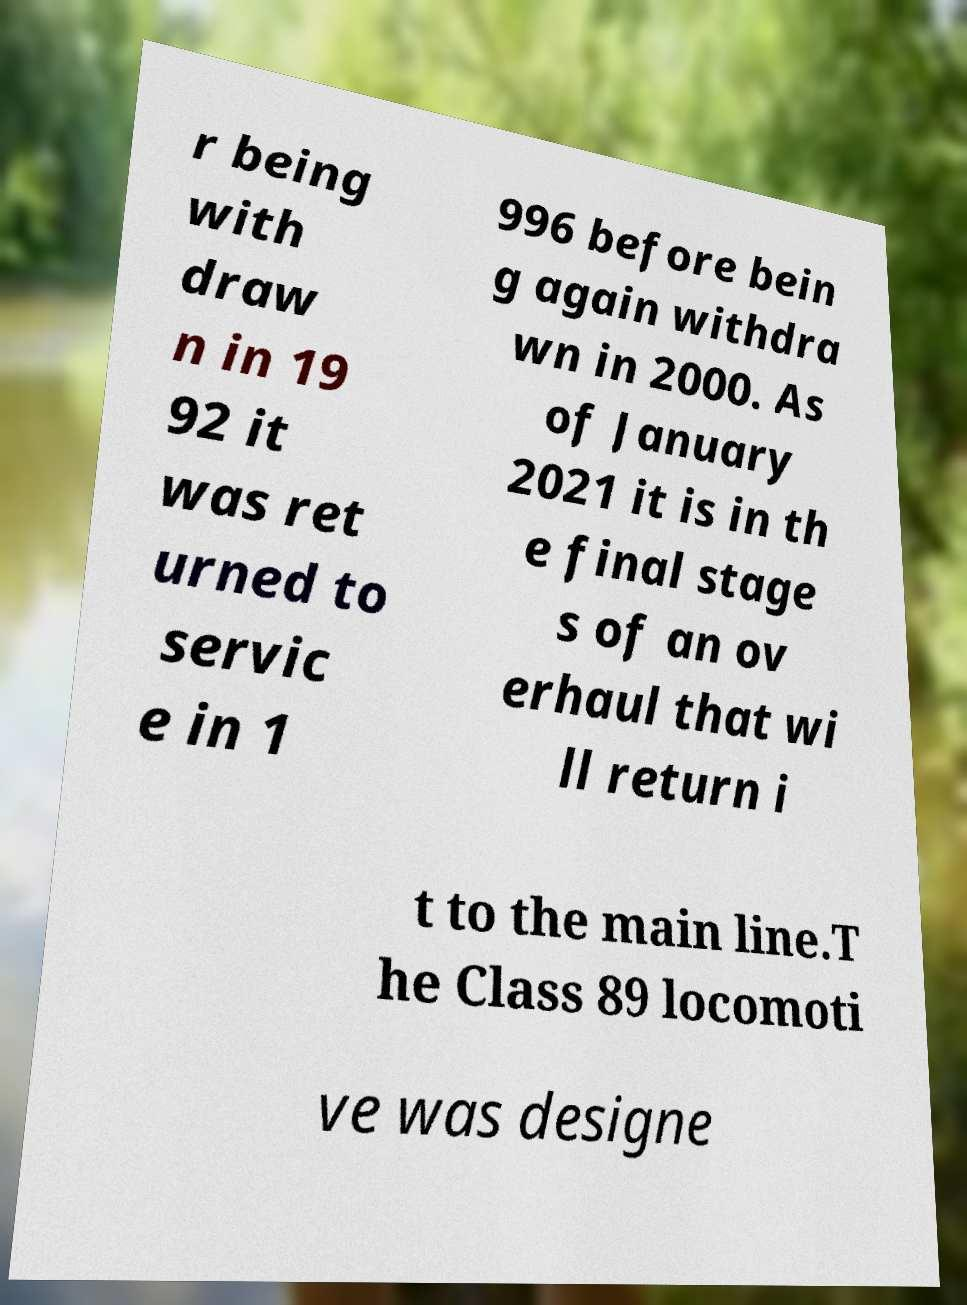For documentation purposes, I need the text within this image transcribed. Could you provide that? r being with draw n in 19 92 it was ret urned to servic e in 1 996 before bein g again withdra wn in 2000. As of January 2021 it is in th e final stage s of an ov erhaul that wi ll return i t to the main line.T he Class 89 locomoti ve was designe 